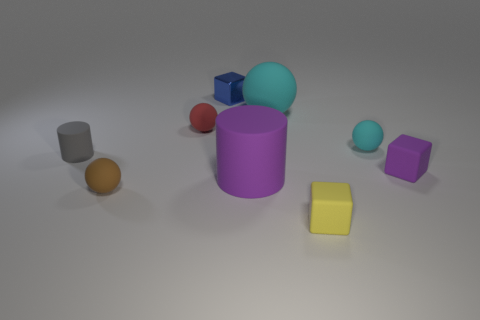Subtract all cyan balls. How many were subtracted if there are1cyan balls left? 1 Subtract all small metallic cubes. How many cubes are left? 2 Subtract all cylinders. How many objects are left? 7 Add 8 small yellow things. How many small yellow things are left? 9 Add 9 tiny blue metal objects. How many tiny blue metal objects exist? 10 Add 1 cylinders. How many objects exist? 10 Subtract all cyan spheres. How many spheres are left? 2 Subtract 0 brown cylinders. How many objects are left? 9 Subtract all brown cubes. Subtract all blue cylinders. How many cubes are left? 3 Subtract all yellow cylinders. How many gray cubes are left? 0 